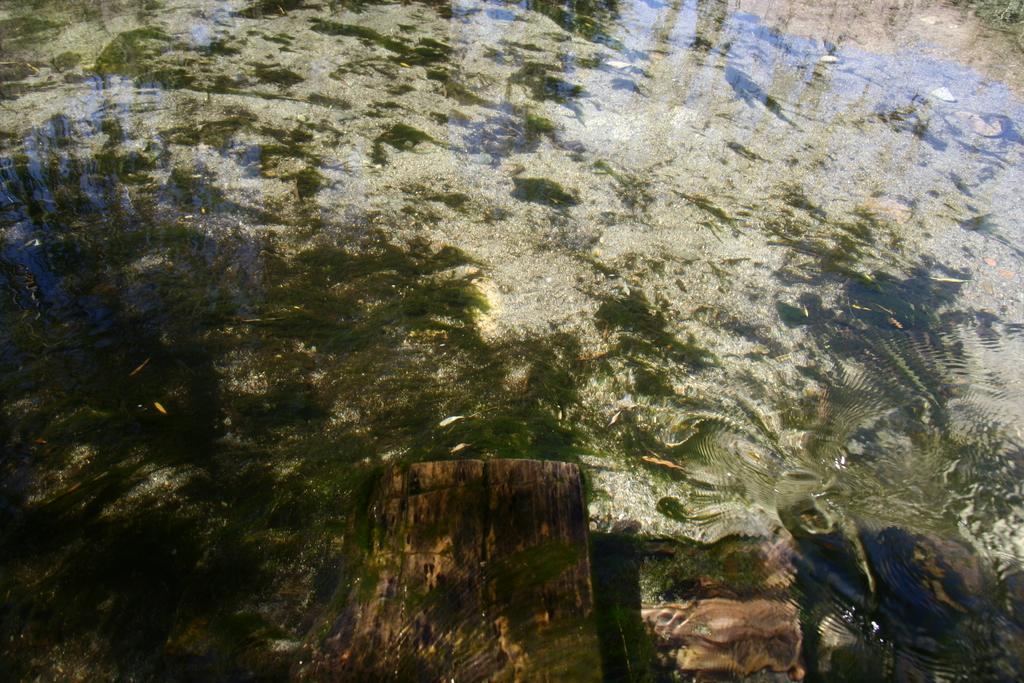Could you give a brief overview of what you see in this image? In this image we can see the water. 